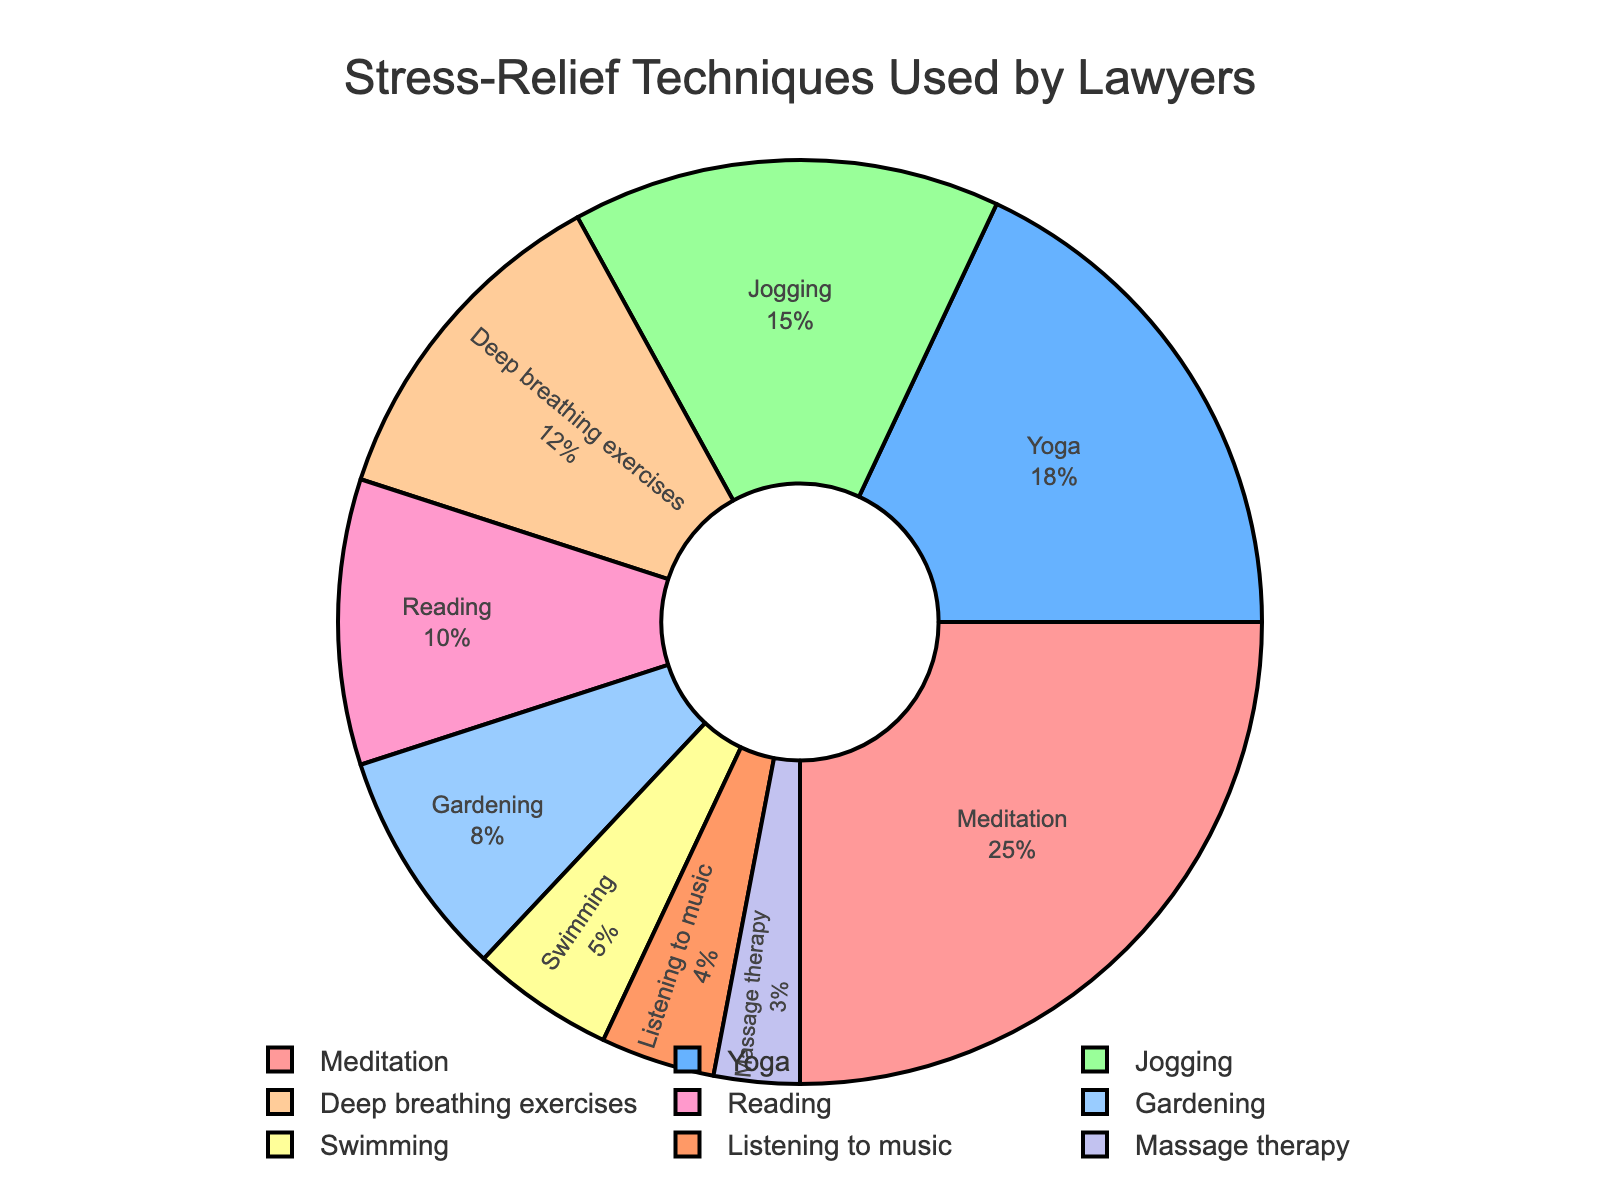Which stress-relief technique is most commonly used by lawyers outside of Pilates sessions? The pie chart shows various stress-relief techniques, and the largest segment represents Meditation with a percentage of 25%.
Answer: Meditation Which is more popular among lawyers for stress relief: Swimming or Gardening? By comparing the sizes of the segments for Swimming and Gardening, we see that Gardening has a percentage of 8%, while Swimming has 5%. Therefore, Gardening is more popular.
Answer: Gardening When comparing Jogging and Deep breathing exercises, which is more commonly used, and by how much more? Jogging has a percentage of 15% and Deep breathing exercises have 12%. To find the difference, we subtract 12% from 15%, which results in 3%.
Answer: Jogging, by 3% What is the combined percentage for lawyers using Yoga and Reading for stress relief? Yoga has a percentage of 18% and Reading has 10%. Adding these together, we get 18% + 10% = 28%.
Answer: 28% How much bigger is the meditation segment compared to the massage therapy segment in the chart? Meditation represents 25% and Massage therapy represents 3%. Subtracting these values gives 25% - 3% = 22%. Meditation is 22% bigger than Massage therapy.
Answer: 22% What percentage of lawyers use either Deep breathing exercises or Listening to music? Deep breathing exercises have 12% and Listening to music has 4%. Adding these together, we get 12% + 4% = 16%.
Answer: 16% Which technique has the least percentage representation, and what color is used for this segment? The technique with the least percentage is Massage therapy at 3%. The color used for this segment is identified through the legend and the pie chart display, which is the ninth color in the color sequence.
Answer: Massage therapy, light purple (or the ninth color) What percentage of lawyers use activities other than Meditation, Yoga, and Jogging combined? The combined percentage of Meditation, Yoga, and Jogging is 25% + 18% + 15% = 58%. To find the percentage for the other activities, subtract this from 100%. 100% - 58% = 42%.
Answer: 42% Does Reading have a higher percentage than any activities colored in shades of blue? According to the legend, Listening to music (4%) and Gardening (8%) are shaded in blue. Reading has a percentage of 10%, which is higher than both.
Answer: Yes 